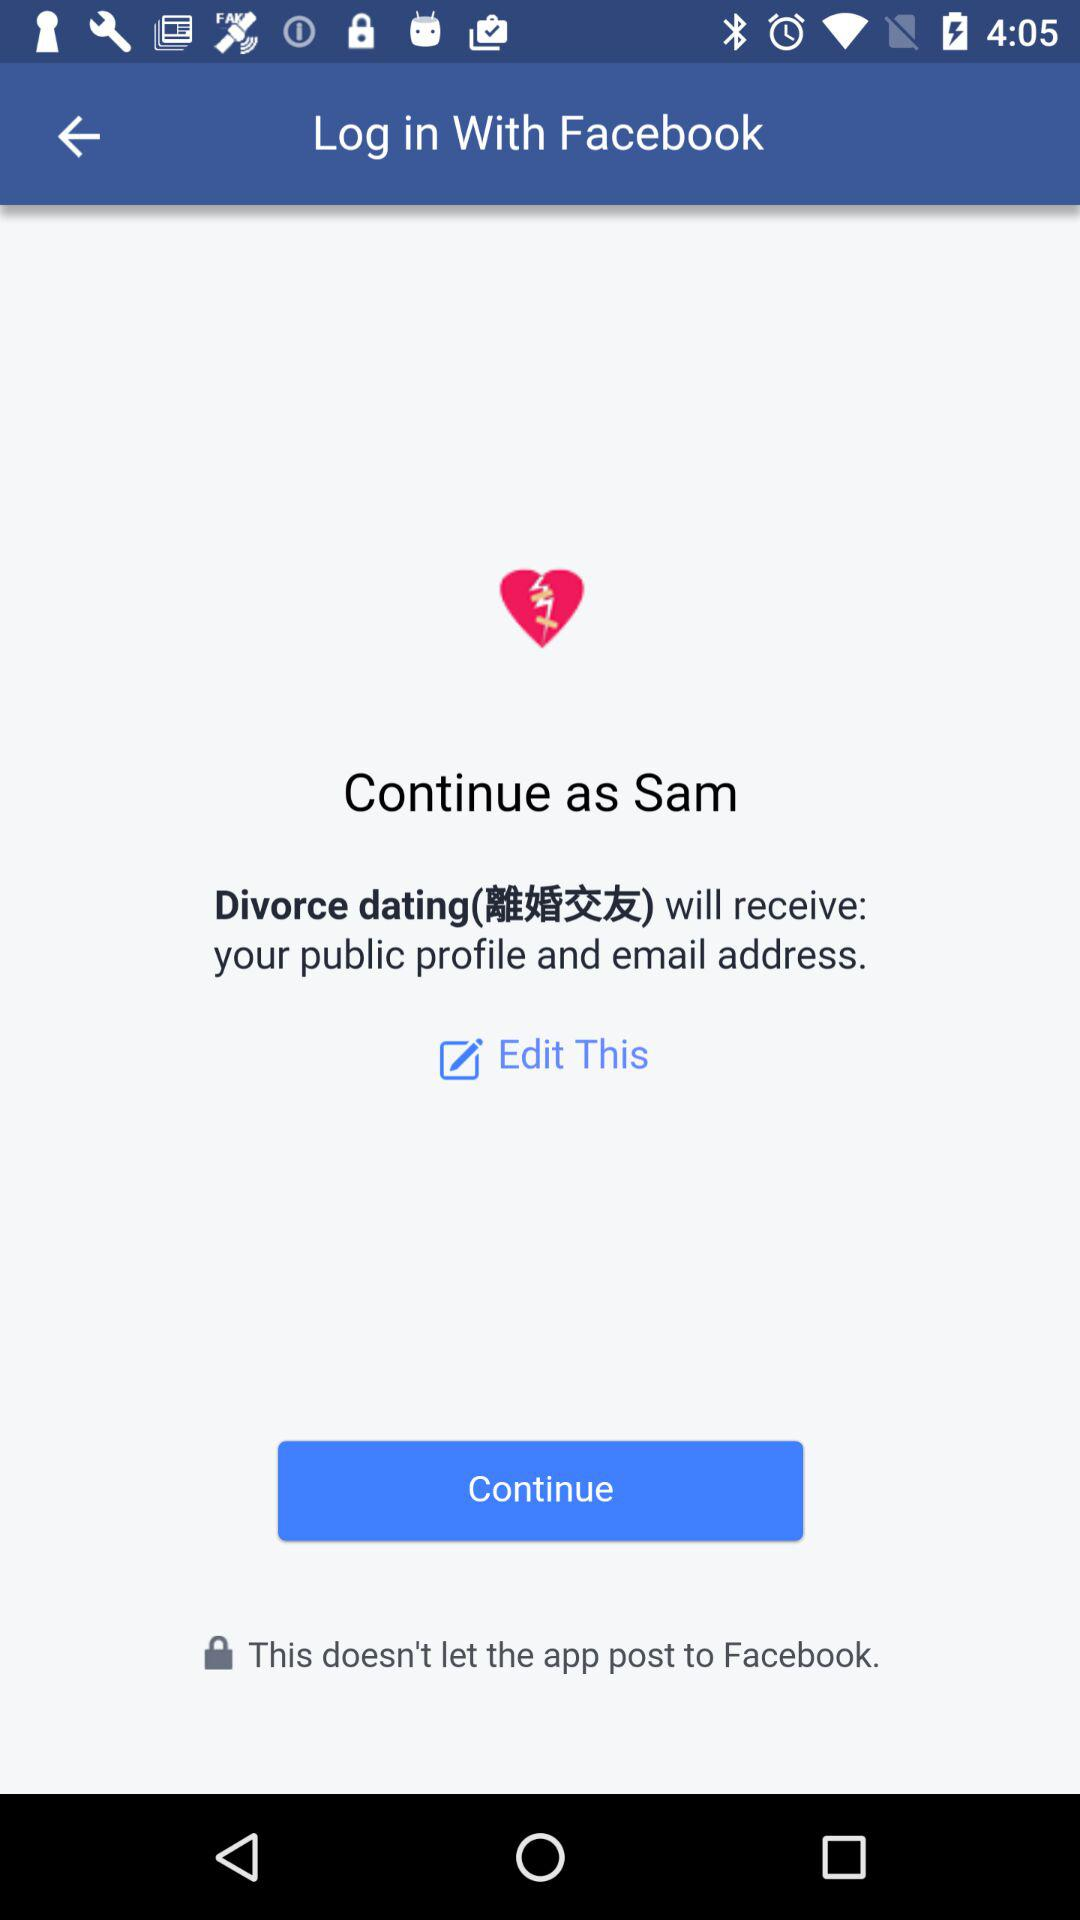What is the shown login name? The shown login name is Sam. 